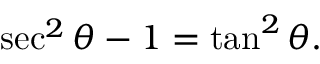<formula> <loc_0><loc_0><loc_500><loc_500>\sec ^ { 2 } \theta - 1 = \tan ^ { 2 } \theta .</formula> 